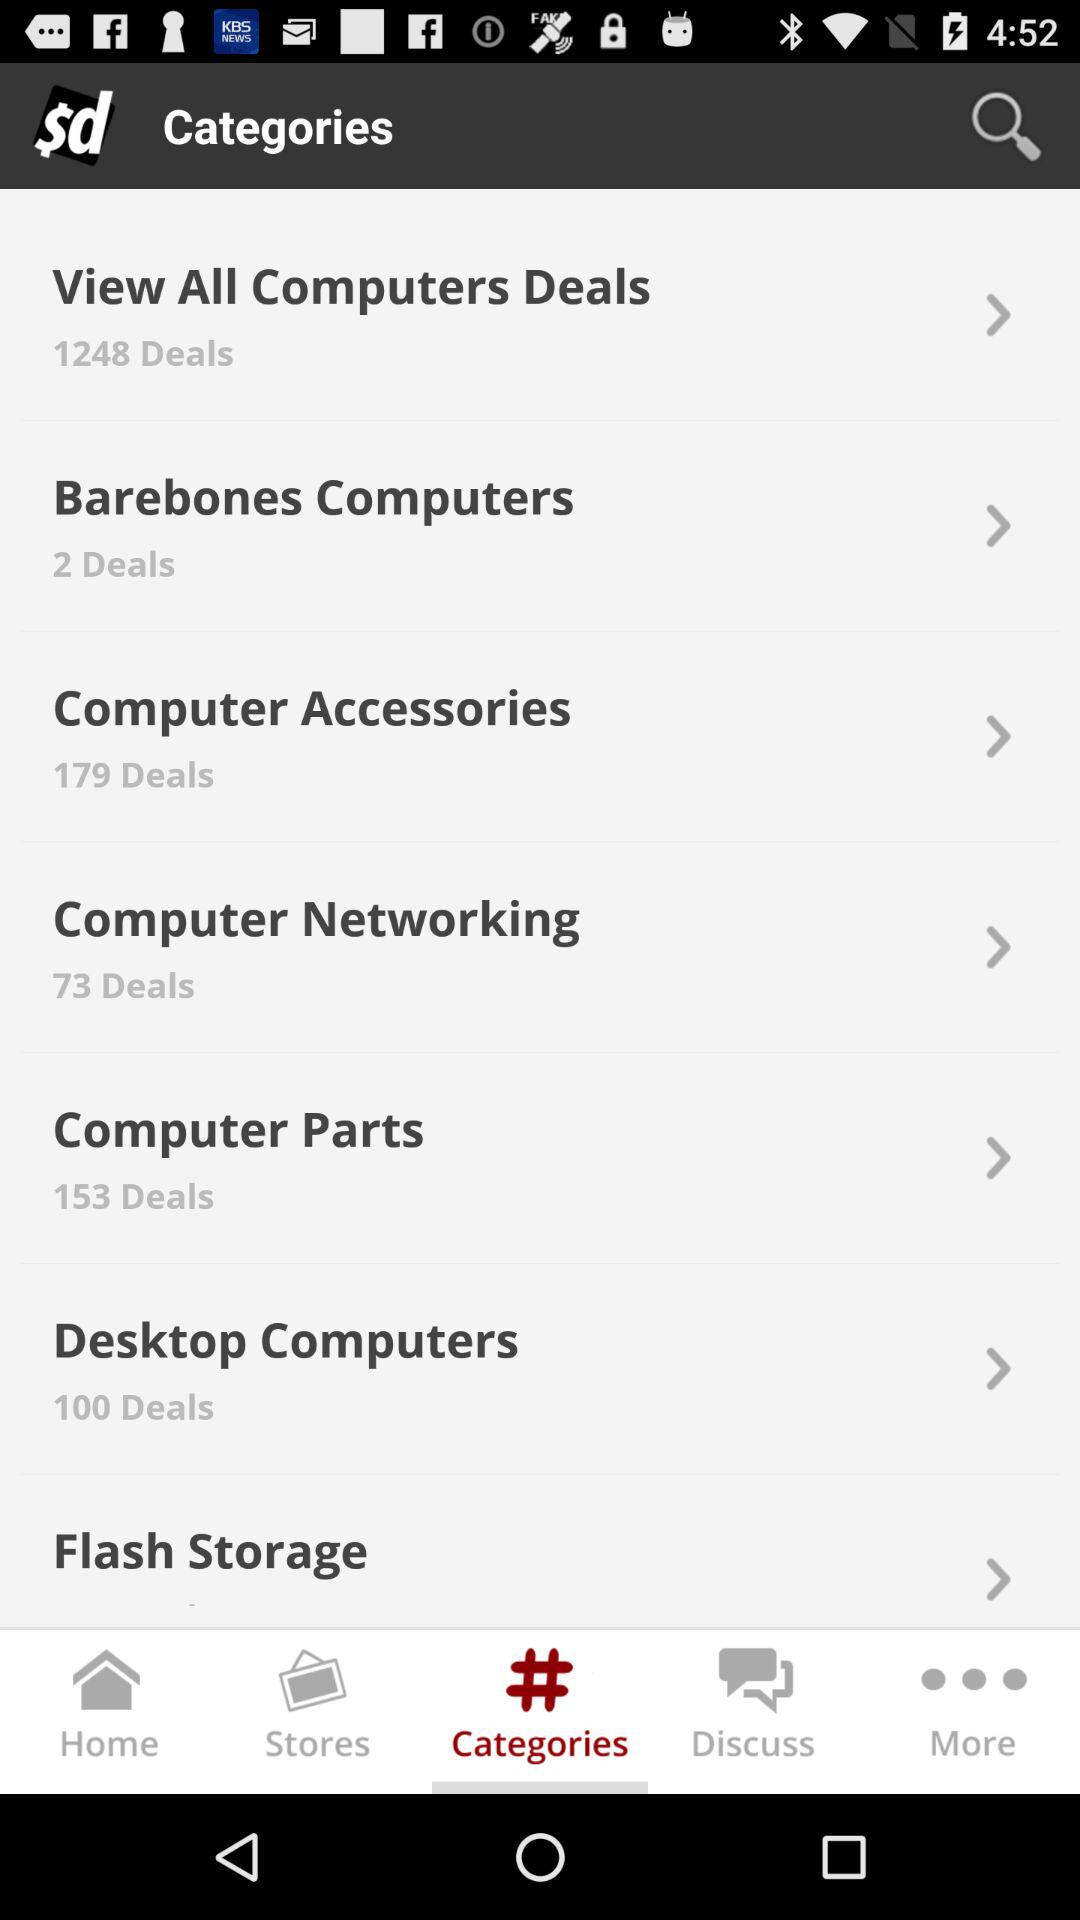What are the different available deal categories? The different available deal categories are "View All Computers Deals", "Barebones Computers", "Computer Accessories", "Computer Networking", "Computer Parts", "Desktop Computers" and "Flash Storage". 